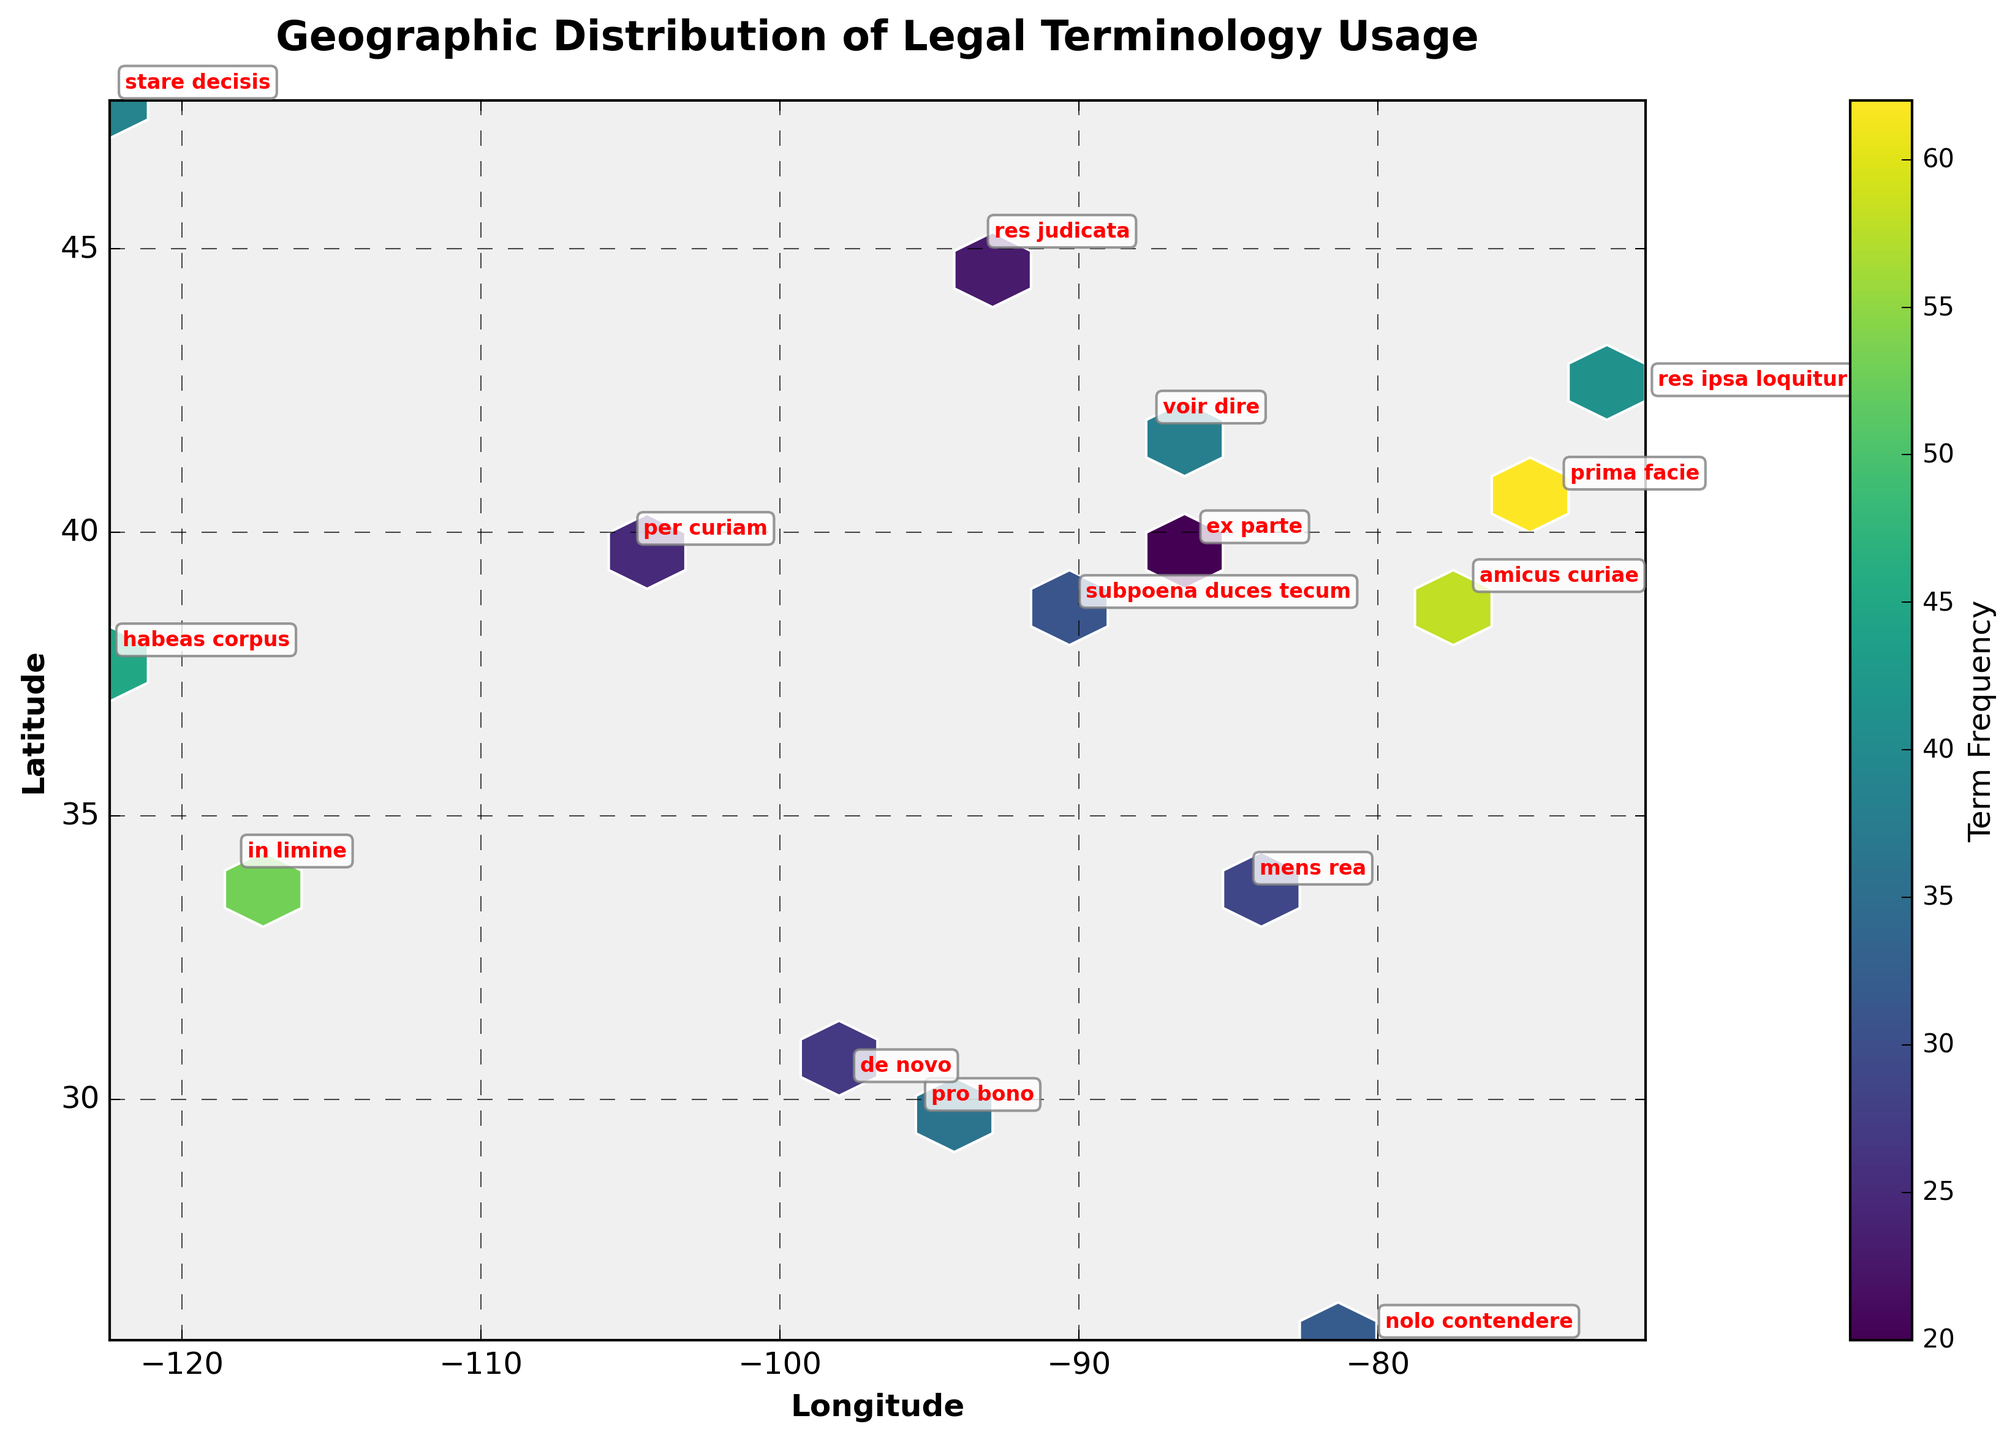What is the title of the plot? The title of the plot is typically found at the top center of the figure. In this case, it clearly reads "Geographic Distribution of Legal Terminology Usage".
Answer: Geographic Distribution of Legal Terminology Usage How many data points are shown in the plot? The number of data points can be counted by looking at the distinct annotated legal terms on the plot. Each term corresponds to one data point. There are 15 different legal terms displayed.
Answer: 15 Which legal term has the highest frequency? To find the legal term with the highest frequency, one must look for the hexbin with the highest color intensity and then check the annotation for that specific location. The term is "prima facie" with a frequency of 62.
Answer: prima facie What geographic location has the highest frequency of 'amicus curiae'? First, locate the annotation for 'amicus curiae'. Then, find its corresponding geographic coordinates on the plot, which is around Washington, D.C. (longitude -77.0369, latitude 38.9072).
Answer: Washington, D.C What are the longitude and latitude axes labeled as? The axis labels can be found directly next to each axis. The horizontal axis (x-axis) is labeled "Longitude" and the vertical axis (y-axis) is labeled "Latitude".
Answer: Longitude and Latitude Which region has the most clustered usage of legal terms? By observing the density of the hexagons, the region around New York City (longitude -74.0060, latitude 40.7128) has the highest cluster of usage, indicating frequent legal terminology usage there.
Answer: New York City Is the frequency of legal term usage higher on the East Coast or the West Coast? Comparing the color intensity on the East Coast (e.g., New York City) and the West Coast (e.g., San Francisco), the East Coast shows more areas with higher frequency. Thus, legal term usage is higher on the East Coast.
Answer: East Coast How is the range of term frequencies represented in the plot? The range of term frequencies is represented by the color gradient in the plot, with the color bar on the right-hand side indicating that lighter shades correspond to lower frequencies and darker shades to higher frequencies.
Answer: Color gradient What legal term has the lowest frequency, and where is it located? To find the term with the lowest frequency, look for the annotation with the least intense color corresponding to frequency. The term "ex parte" has a frequency of 20 and is located in Indianapolis (longitude -86.1581, latitude 39.7684).
Answer: ex parte in Indianapolis Which legal terms are found in coastal cities? Identify the annotations near coastal cities. Terms like "habeas corpus" in San Francisco, "in limine" in Los Angeles, and "prima facie" in New York City are in coastal cities.
Answer: habeas corpus, in limine, prima facie 